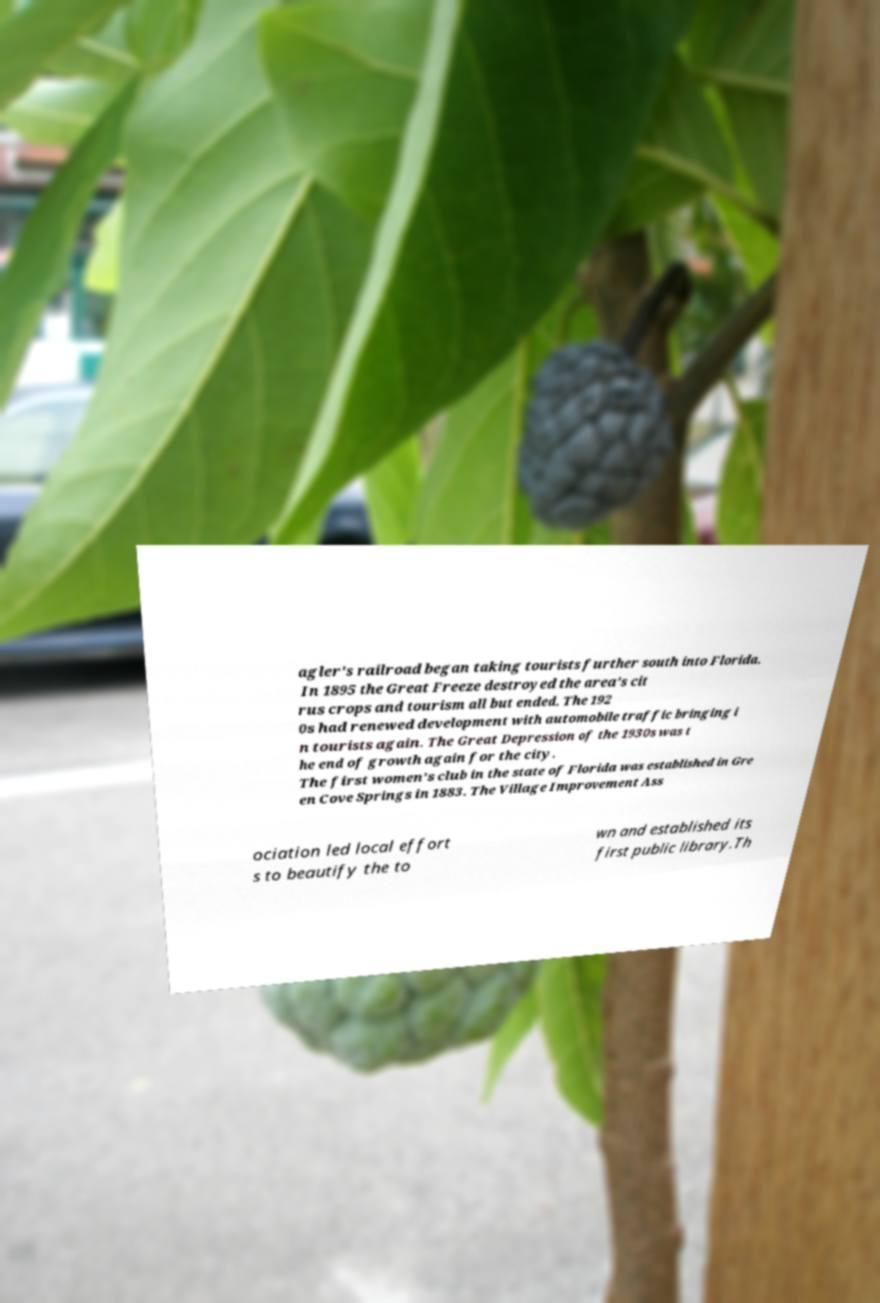What messages or text are displayed in this image? I need them in a readable, typed format. agler's railroad began taking tourists further south into Florida. In 1895 the Great Freeze destroyed the area's cit rus crops and tourism all but ended. The 192 0s had renewed development with automobile traffic bringing i n tourists again. The Great Depression of the 1930s was t he end of growth again for the city. The first women's club in the state of Florida was established in Gre en Cove Springs in 1883. The Village Improvement Ass ociation led local effort s to beautify the to wn and established its first public library.Th 